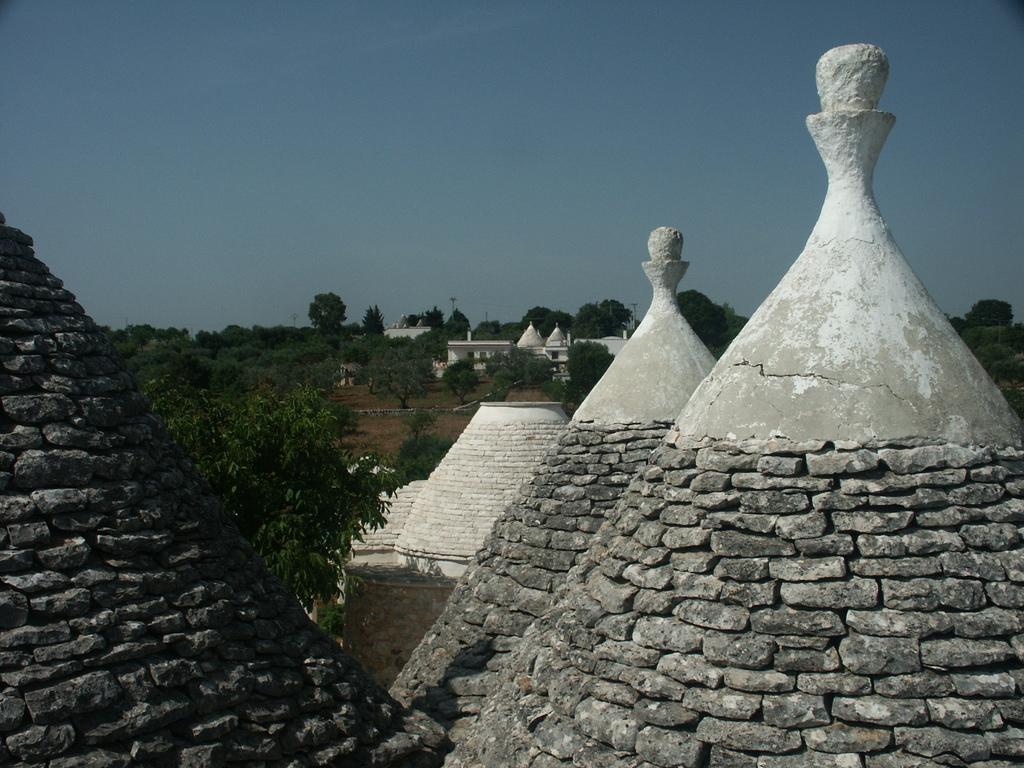Describe this image in one or two sentences. In this image we can see a group of buildings made with stones. In the background, we can see a group of trees, building and sky. 